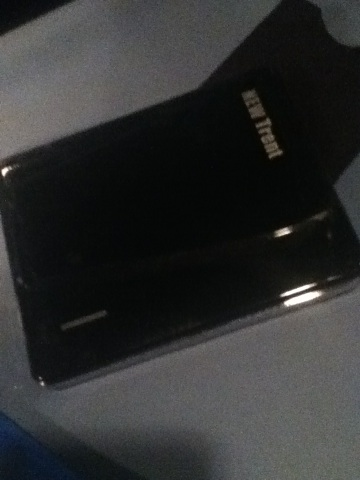Can you tell what this object is used for? The object in the image appears to be an external hard drive, typically used for storing and backing up data for computers. What are the typical capacities for such devices? External hard drives come in a variety of storage capacities. Common sizes include 500GB, 1TB, 2TB, and even up to 8TB or more. The right capacity depends on your storage needs, whether it be for personal, gaming, or professional use. 